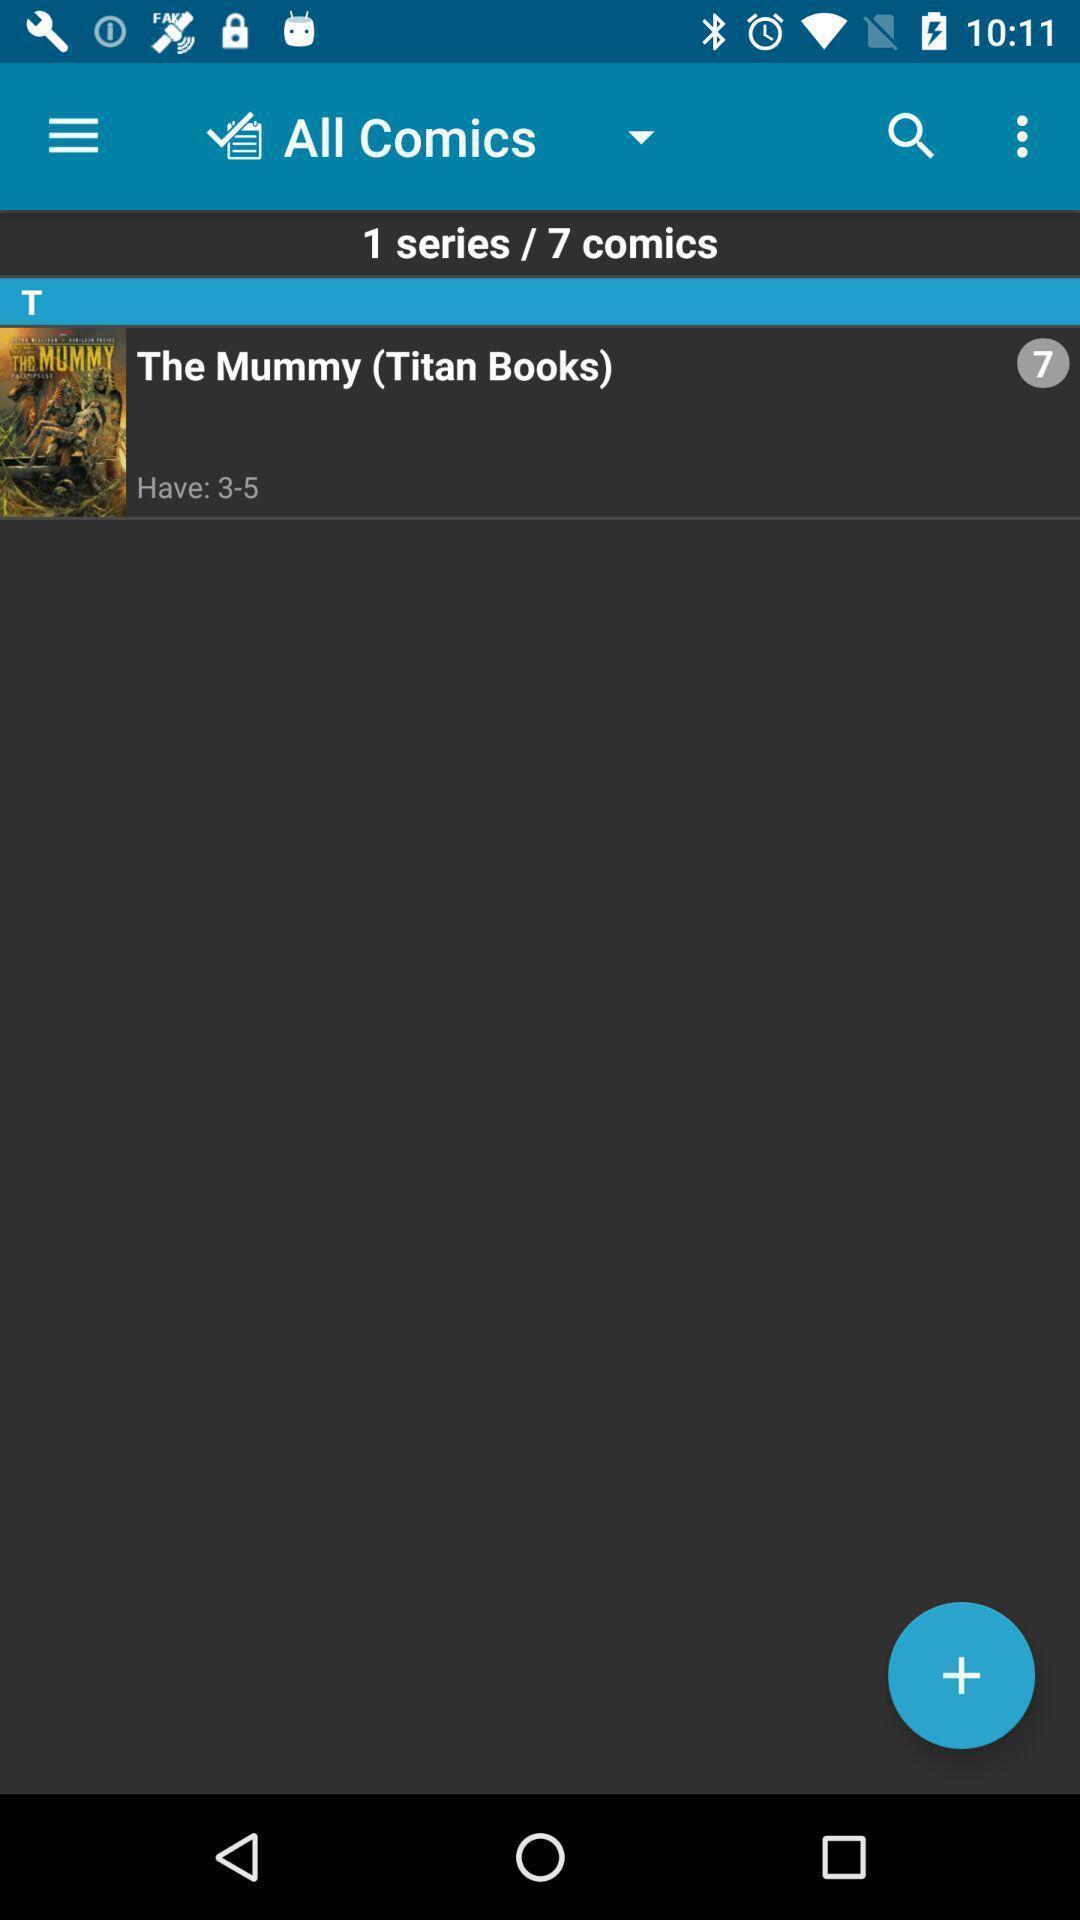Describe the visual elements of this screenshot. Window displaying a comic book. 